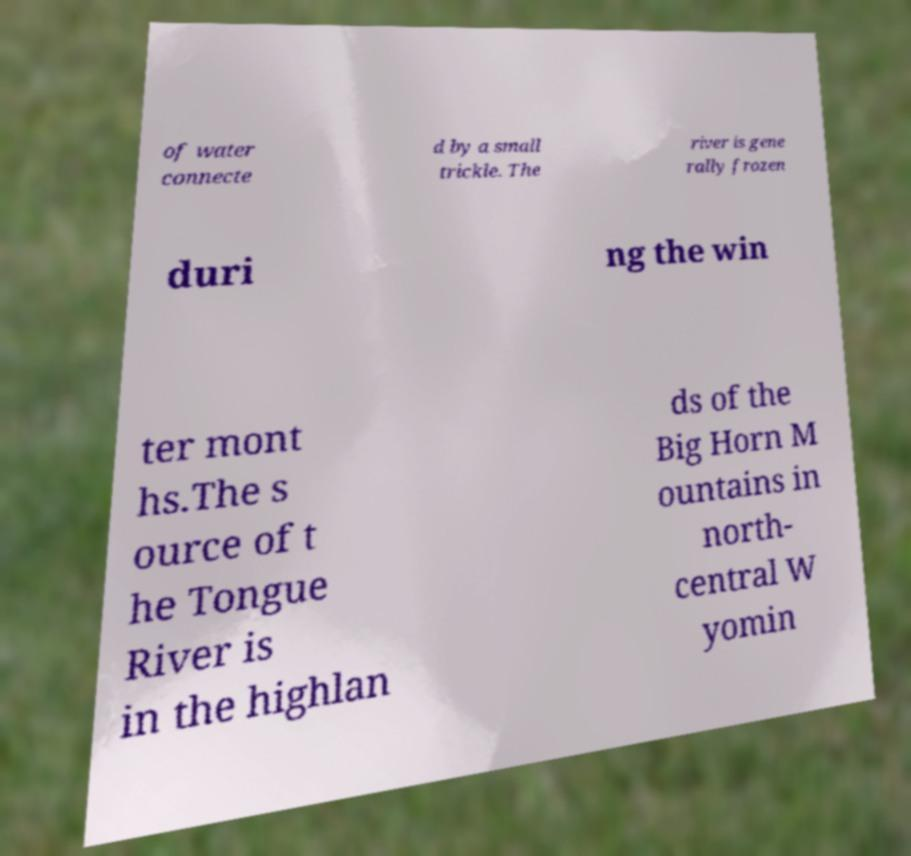For documentation purposes, I need the text within this image transcribed. Could you provide that? of water connecte d by a small trickle. The river is gene rally frozen duri ng the win ter mont hs.The s ource of t he Tongue River is in the highlan ds of the Big Horn M ountains in north- central W yomin 